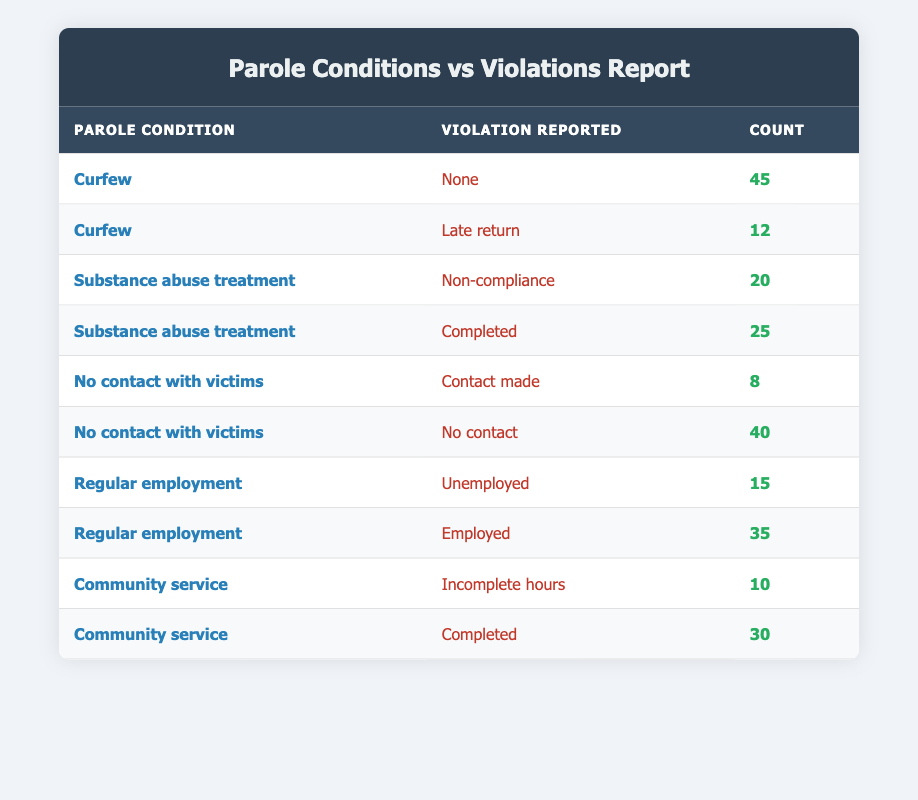What is the total count of violations reported for the condition "Curfew"? To find the total count for "Curfew," we need to add the counts for the violations listed under this condition: None (45) + Late return (12) = 57
Answer: 57 How many individuals reported no contact while having the condition "No contact with victims"? The count for the violation "No contact" under the condition "No contact with victims" is 40, indicating this many individuals complied with their condition
Answer: 40 What is the total number of individuals who completed their community service hours? The count for the violation "Completed" under the condition "Community service" is 30, which reflects the number of individuals who fulfilled this requirement
Answer: 30 Is it true that more individuals reported being employed than unemployed under the condition "Regular employment"? Under "Regular employment," the count for "Employed" is 35, while the count for "Unemployed" is 15. Since 35 is greater than 15, the statement is true
Answer: Yes What is the difference in the number of individuals who reported being non-compliant versus those who successfully completed their substance abuse treatment? For "Substance abuse treatment," the count for "Non-compliance" is 20 and for "Completed" is 25. The difference is 25 - 20 = 5, indicating that 5 more individuals completed their treatment than were non-compliant
Answer: 5 How many total violations were reported across all conditions? To find the total violations, we sum all the counts: 45 + 12 + 20 + 25 + 8 + 40 + 15 + 35 + 10 + 30 =  215. Thus, the total count of all reported violations is 215
Answer: 215 What percentage of individuals under the "Substance abuse treatment" condition completed this requirement? The counts are 20 for "Non-compliance" and 25 for "Completed." The total is 20 + 25 = 45. The percentage who completed is (25/45) * 100 = 55.56%. Thus, approximately 55.56% of individuals completed their treatment
Answer: 55.56% Which parole condition had the highest report of violations, and what is that count? Comparing the violation counts: "Curfew" (57), "Substance abuse treatment" (45), "No contact with victims" (48), "Regular employment" (50), and "Community service" (40). The highest is "Curfew" with a total of 57 violations
Answer: Curfew, 57 What is the total count of individuals who violated the condition related to "Community service"? Under "Community service," the counts are 10 for "Incomplete hours" and 30 for "Completed." Therefore, total violations reported for "Community service" is 10
Answer: 10 